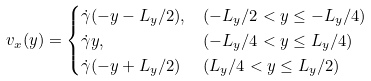<formula> <loc_0><loc_0><loc_500><loc_500>v _ { x } ( y ) & = \begin{cases} \dot { \gamma } ( - y - L _ { y } / 2 ) , & ( - L _ { y } / 2 < y \leq - L _ { y } / 4 ) \\ \dot { \gamma } y , & ( - L _ { y } / 4 < y \leq L _ { y } / 4 ) \\ \dot { \gamma } ( - y + L _ { y } / 2 ) & ( L _ { y } / 4 < y \leq L _ { y } / 2 ) \\ \end{cases}</formula> 